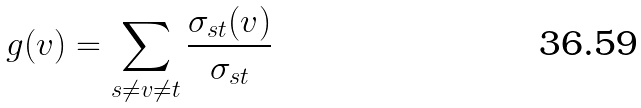Convert formula to latex. <formula><loc_0><loc_0><loc_500><loc_500>g ( v ) = \sum _ { s \neq v \neq t } \frac { \sigma _ { s t } ( v ) } { \sigma _ { s t } }</formula> 